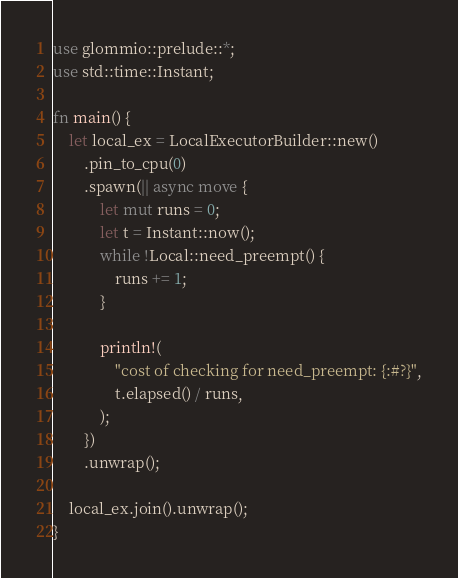Convert code to text. <code><loc_0><loc_0><loc_500><loc_500><_Rust_>use glommio::prelude::*;
use std::time::Instant;

fn main() {
    let local_ex = LocalExecutorBuilder::new()
        .pin_to_cpu(0)
        .spawn(|| async move {
            let mut runs = 0;
            let t = Instant::now();
            while !Local::need_preempt() {
                runs += 1;
            }

            println!(
                "cost of checking for need_preempt: {:#?}",
                t.elapsed() / runs,
            );
        })
        .unwrap();

    local_ex.join().unwrap();
}
</code> 